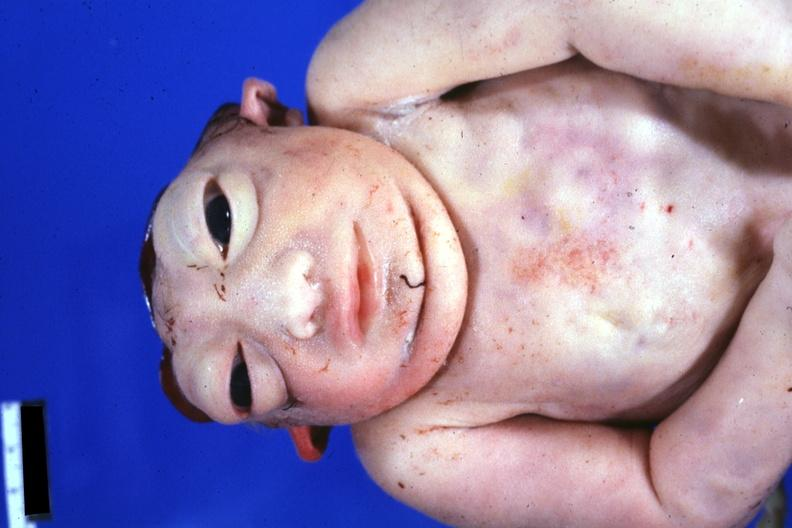what is present?
Answer the question using a single word or phrase. Anencephaly 